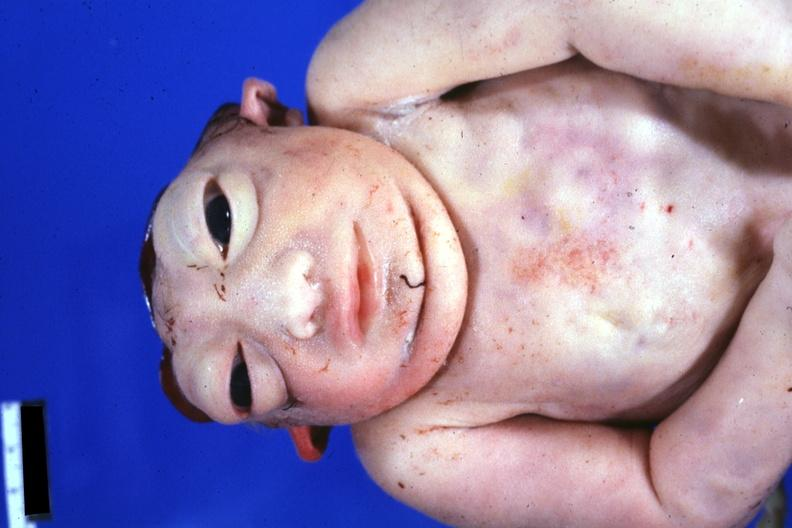what is present?
Answer the question using a single word or phrase. Anencephaly 